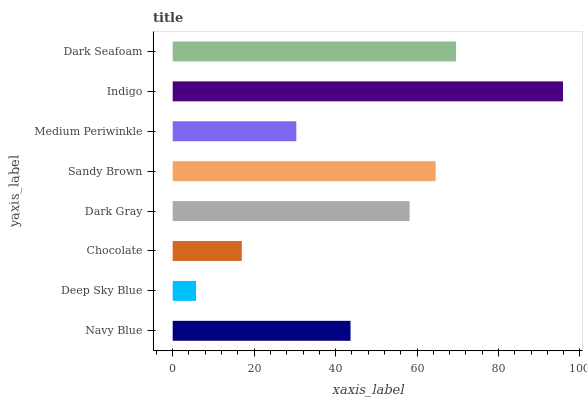Is Deep Sky Blue the minimum?
Answer yes or no. Yes. Is Indigo the maximum?
Answer yes or no. Yes. Is Chocolate the minimum?
Answer yes or no. No. Is Chocolate the maximum?
Answer yes or no. No. Is Chocolate greater than Deep Sky Blue?
Answer yes or no. Yes. Is Deep Sky Blue less than Chocolate?
Answer yes or no. Yes. Is Deep Sky Blue greater than Chocolate?
Answer yes or no. No. Is Chocolate less than Deep Sky Blue?
Answer yes or no. No. Is Dark Gray the high median?
Answer yes or no. Yes. Is Navy Blue the low median?
Answer yes or no. Yes. Is Dark Seafoam the high median?
Answer yes or no. No. Is Dark Gray the low median?
Answer yes or no. No. 